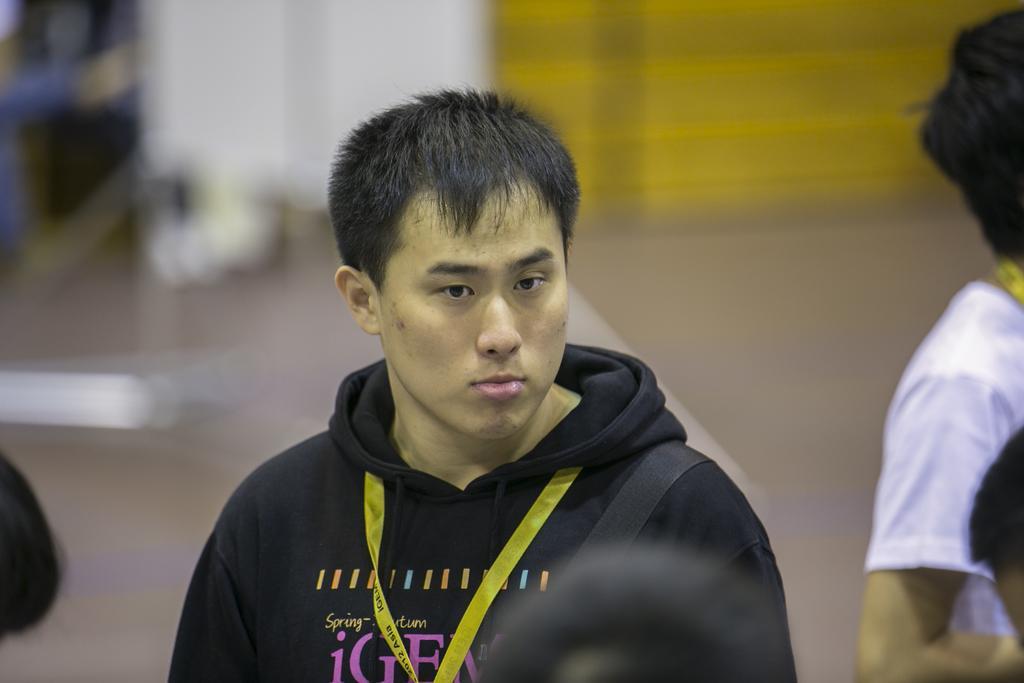How would you summarize this image in a sentence or two? In the picture we can see a man standing and he is wearing a hoodie and a yellow color tag in the neck and besides the man also we can see some people standing. 